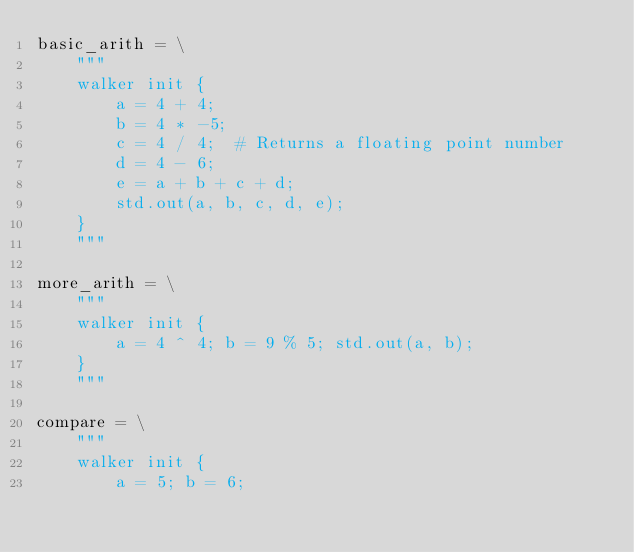<code> <loc_0><loc_0><loc_500><loc_500><_Python_>basic_arith = \
    """
    walker init {
        a = 4 + 4;
        b = 4 * -5;
        c = 4 / 4;  # Returns a floating point number
        d = 4 - 6;
        e = a + b + c + d;
        std.out(a, b, c, d, e);
    }
    """

more_arith = \
    """
    walker init {
        a = 4 ^ 4; b = 9 % 5; std.out(a, b);
    }
    """

compare = \
    """
    walker init {
        a = 5; b = 6;</code> 